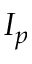<formula> <loc_0><loc_0><loc_500><loc_500>I _ { p }</formula> 